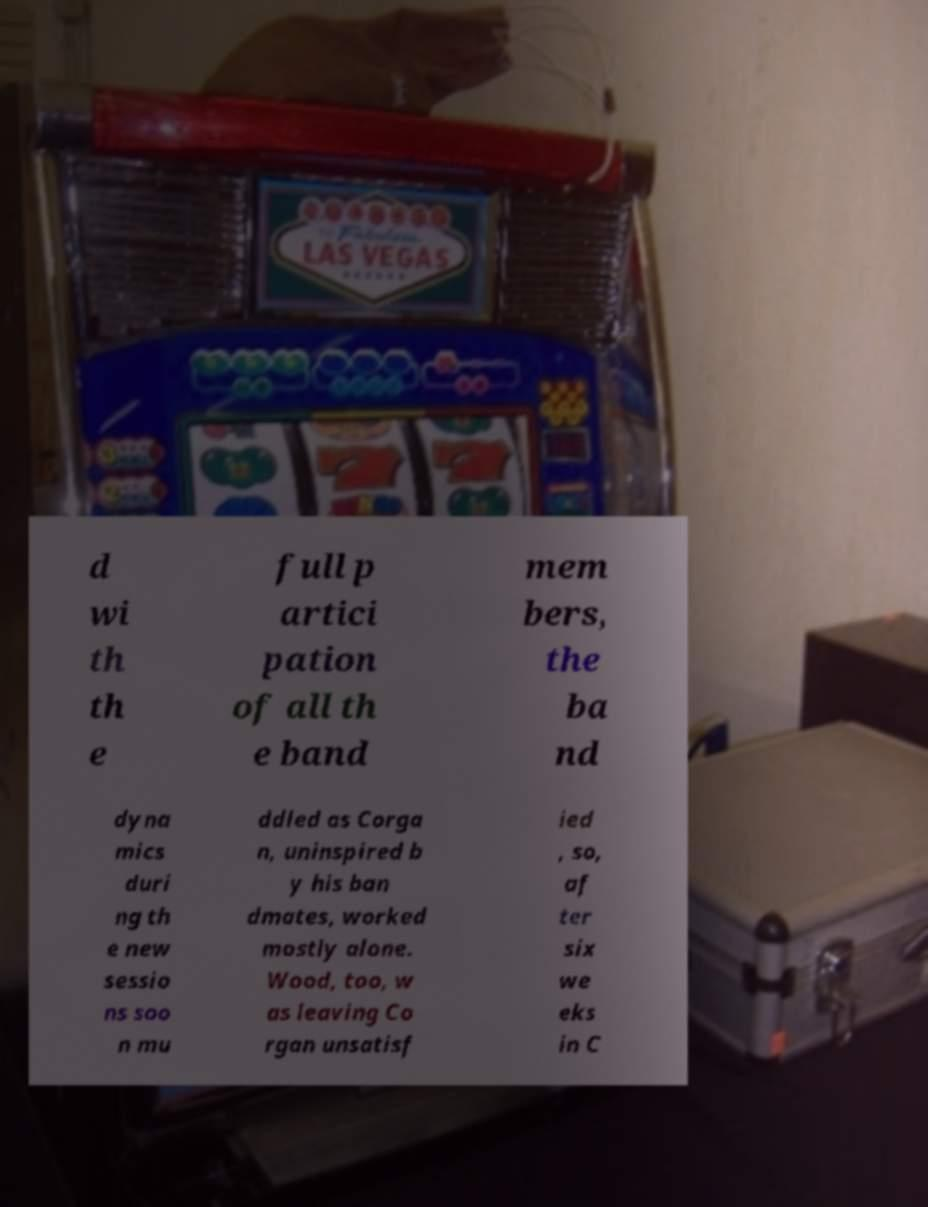Can you accurately transcribe the text from the provided image for me? d wi th th e full p artici pation of all th e band mem bers, the ba nd dyna mics duri ng th e new sessio ns soo n mu ddled as Corga n, uninspired b y his ban dmates, worked mostly alone. Wood, too, w as leaving Co rgan unsatisf ied , so, af ter six we eks in C 